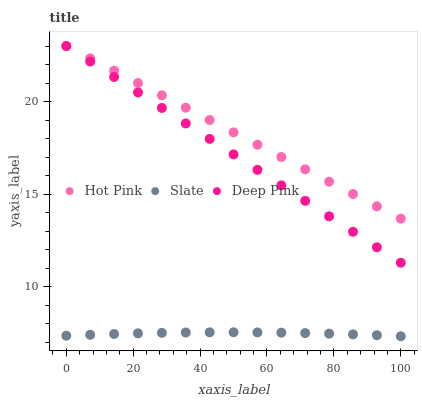Does Slate have the minimum area under the curve?
Answer yes or no. Yes. Does Hot Pink have the maximum area under the curve?
Answer yes or no. Yes. Does Deep Pink have the minimum area under the curve?
Answer yes or no. No. Does Deep Pink have the maximum area under the curve?
Answer yes or no. No. Is Deep Pink the smoothest?
Answer yes or no. Yes. Is Slate the roughest?
Answer yes or no. Yes. Is Hot Pink the smoothest?
Answer yes or no. No. Is Hot Pink the roughest?
Answer yes or no. No. Does Slate have the lowest value?
Answer yes or no. Yes. Does Deep Pink have the lowest value?
Answer yes or no. No. Does Deep Pink have the highest value?
Answer yes or no. Yes. Is Slate less than Hot Pink?
Answer yes or no. Yes. Is Hot Pink greater than Slate?
Answer yes or no. Yes. Does Deep Pink intersect Hot Pink?
Answer yes or no. Yes. Is Deep Pink less than Hot Pink?
Answer yes or no. No. Is Deep Pink greater than Hot Pink?
Answer yes or no. No. Does Slate intersect Hot Pink?
Answer yes or no. No. 